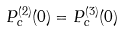Convert formula to latex. <formula><loc_0><loc_0><loc_500><loc_500>P _ { c } ^ { ( 2 ) } ( 0 ) = P _ { c } ^ { ( 3 ) } ( 0 )</formula> 